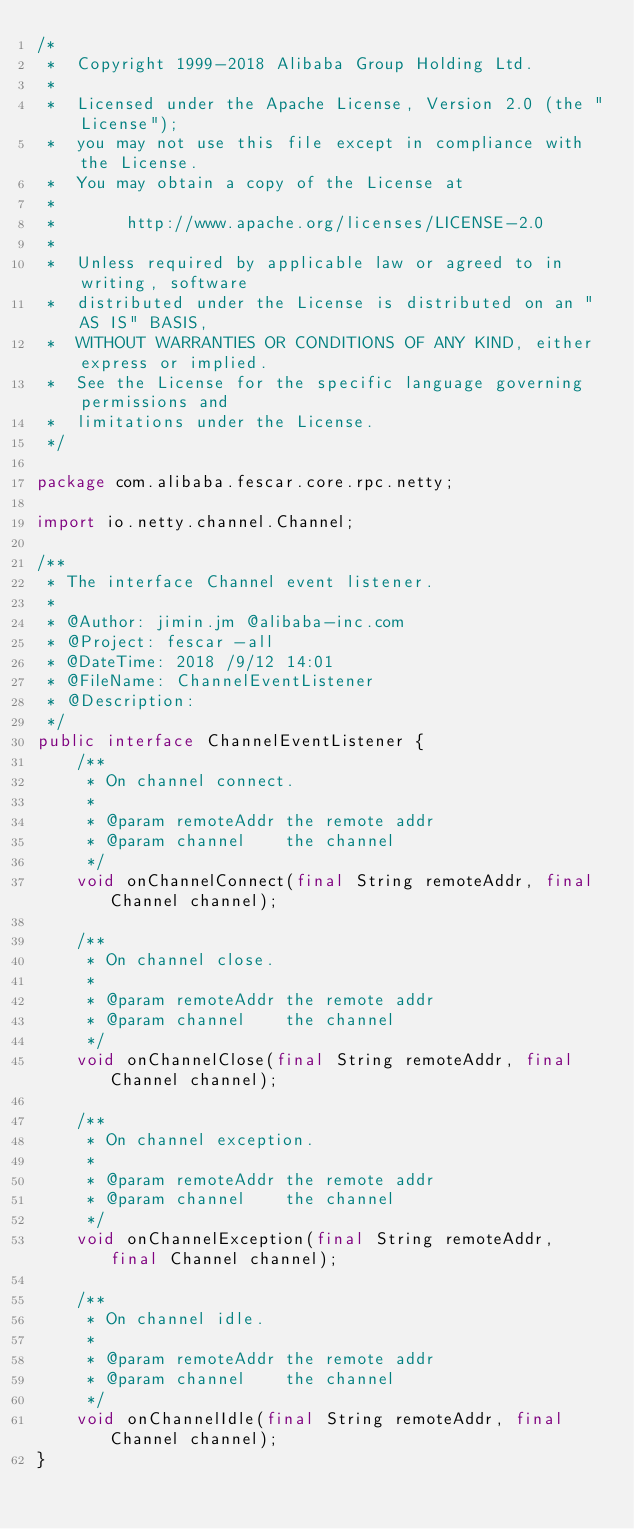Convert code to text. <code><loc_0><loc_0><loc_500><loc_500><_Java_>/*
 *  Copyright 1999-2018 Alibaba Group Holding Ltd.
 *
 *  Licensed under the Apache License, Version 2.0 (the "License");
 *  you may not use this file except in compliance with the License.
 *  You may obtain a copy of the License at
 *
 *       http://www.apache.org/licenses/LICENSE-2.0
 *
 *  Unless required by applicable law or agreed to in writing, software
 *  distributed under the License is distributed on an "AS IS" BASIS,
 *  WITHOUT WARRANTIES OR CONDITIONS OF ANY KIND, either express or implied.
 *  See the License for the specific language governing permissions and
 *  limitations under the License.
 */

package com.alibaba.fescar.core.rpc.netty;

import io.netty.channel.Channel;

/**
 * The interface Channel event listener.
 *
 * @Author: jimin.jm @alibaba-inc.com
 * @Project: fescar -all
 * @DateTime: 2018 /9/12 14:01
 * @FileName: ChannelEventListener
 * @Description:
 */
public interface ChannelEventListener {
    /**
     * On channel connect.
     *
     * @param remoteAddr the remote addr
     * @param channel    the channel
     */
    void onChannelConnect(final String remoteAddr, final Channel channel);

    /**
     * On channel close.
     *
     * @param remoteAddr the remote addr
     * @param channel    the channel
     */
    void onChannelClose(final String remoteAddr, final Channel channel);

    /**
     * On channel exception.
     *
     * @param remoteAddr the remote addr
     * @param channel    the channel
     */
    void onChannelException(final String remoteAddr, final Channel channel);

    /**
     * On channel idle.
     *
     * @param remoteAddr the remote addr
     * @param channel    the channel
     */
    void onChannelIdle(final String remoteAddr, final Channel channel);
}
</code> 